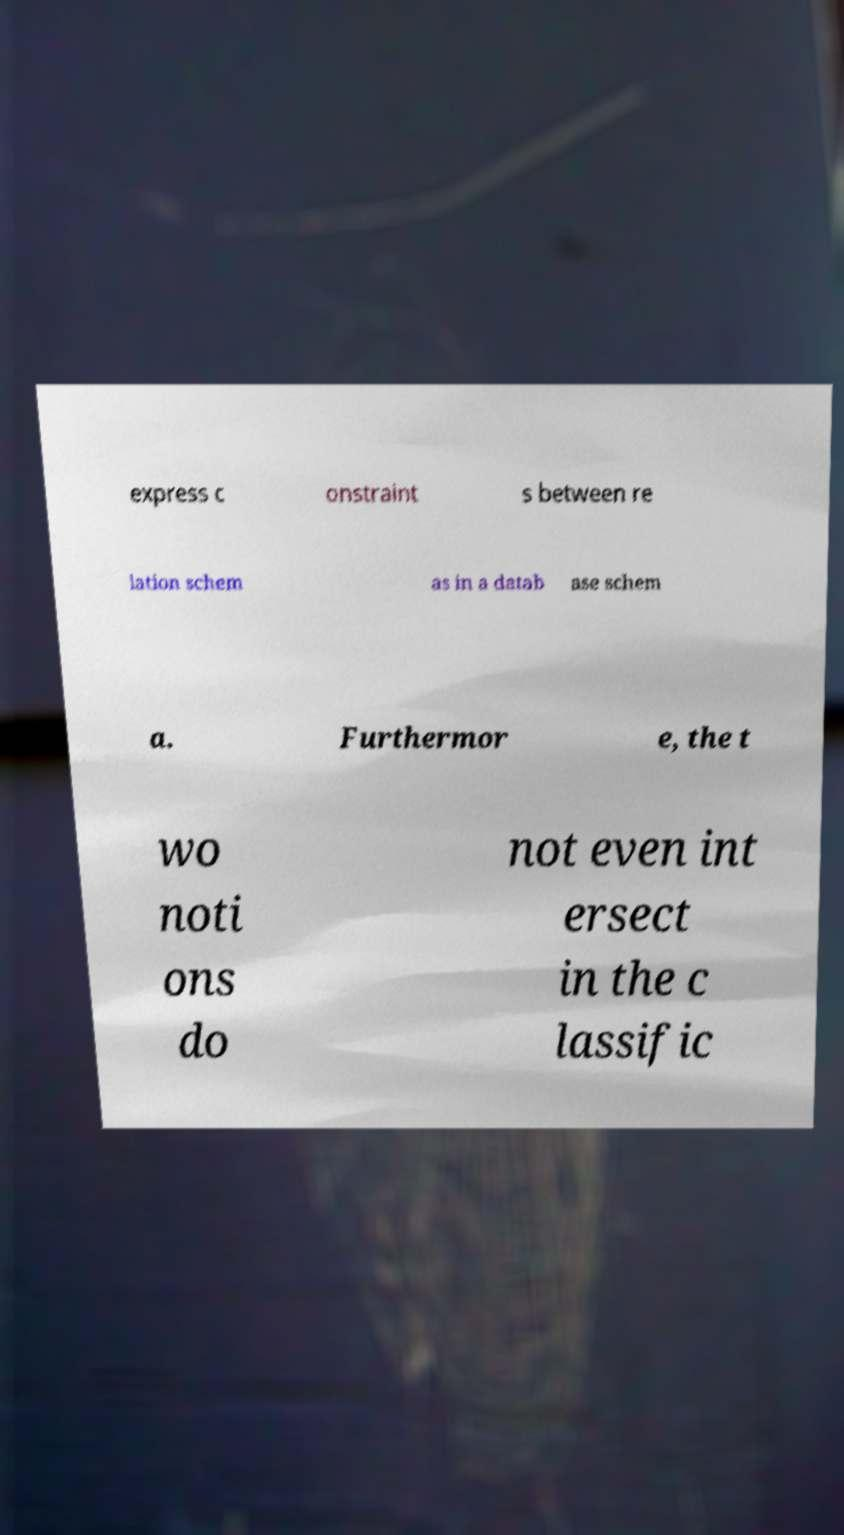Can you accurately transcribe the text from the provided image for me? express c onstraint s between re lation schem as in a datab ase schem a. Furthermor e, the t wo noti ons do not even int ersect in the c lassific 